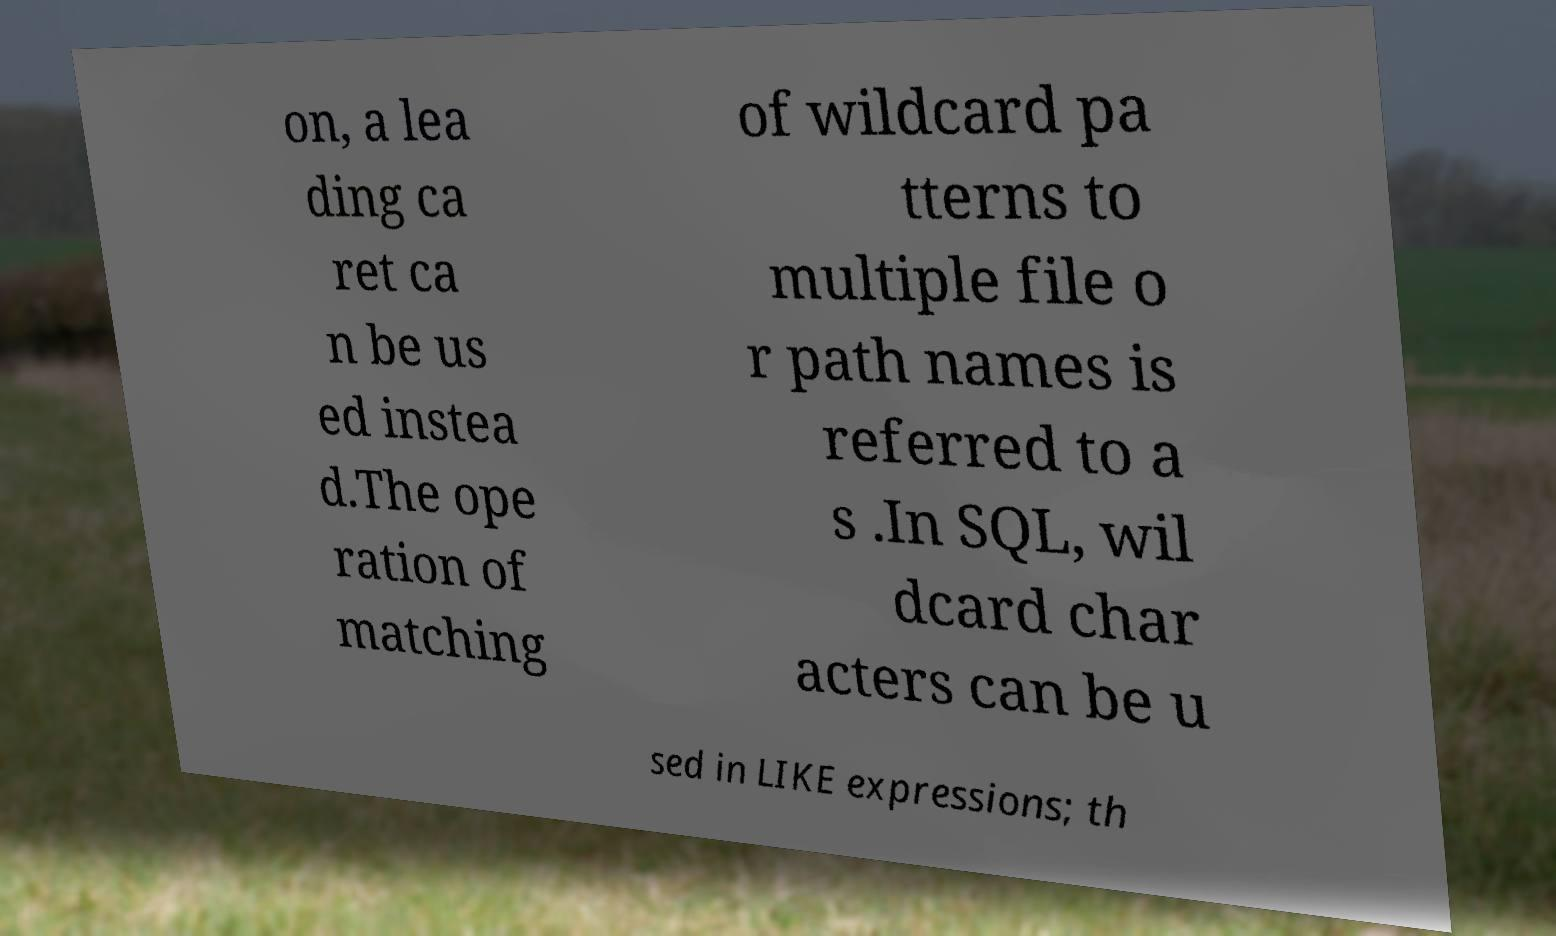I need the written content from this picture converted into text. Can you do that? on, a lea ding ca ret ca n be us ed instea d.The ope ration of matching of wildcard pa tterns to multiple file o r path names is referred to a s .In SQL, wil dcard char acters can be u sed in LIKE expressions; th 